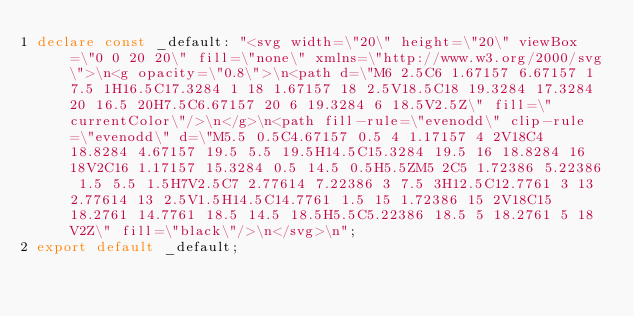Convert code to text. <code><loc_0><loc_0><loc_500><loc_500><_TypeScript_>declare const _default: "<svg width=\"20\" height=\"20\" viewBox=\"0 0 20 20\" fill=\"none\" xmlns=\"http://www.w3.org/2000/svg\">\n<g opacity=\"0.8\">\n<path d=\"M6 2.5C6 1.67157 6.67157 1 7.5 1H16.5C17.3284 1 18 1.67157 18 2.5V18.5C18 19.3284 17.3284 20 16.5 20H7.5C6.67157 20 6 19.3284 6 18.5V2.5Z\" fill=\"currentColor\"/>\n</g>\n<path fill-rule=\"evenodd\" clip-rule=\"evenodd\" d=\"M5.5 0.5C4.67157 0.5 4 1.17157 4 2V18C4 18.8284 4.67157 19.5 5.5 19.5H14.5C15.3284 19.5 16 18.8284 16 18V2C16 1.17157 15.3284 0.5 14.5 0.5H5.5ZM5 2C5 1.72386 5.22386 1.5 5.5 1.5H7V2.5C7 2.77614 7.22386 3 7.5 3H12.5C12.7761 3 13 2.77614 13 2.5V1.5H14.5C14.7761 1.5 15 1.72386 15 2V18C15 18.2761 14.7761 18.5 14.5 18.5H5.5C5.22386 18.5 5 18.2761 5 18V2Z\" fill=\"black\"/>\n</svg>\n";
export default _default;
</code> 